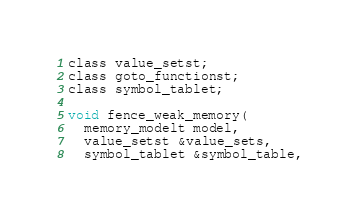<code> <loc_0><loc_0><loc_500><loc_500><_C_>class value_setst;
class goto_functionst;
class symbol_tablet;

void fence_weak_memory(
  memory_modelt model,
  value_setst &value_sets,
  symbol_tablet &symbol_table,</code> 